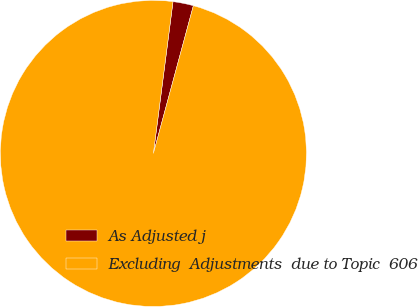Convert chart to OTSL. <chart><loc_0><loc_0><loc_500><loc_500><pie_chart><fcel>As Adjusted j<fcel>Excluding  Adjustments  due to Topic  606<nl><fcel>2.16%<fcel>97.84%<nl></chart> 